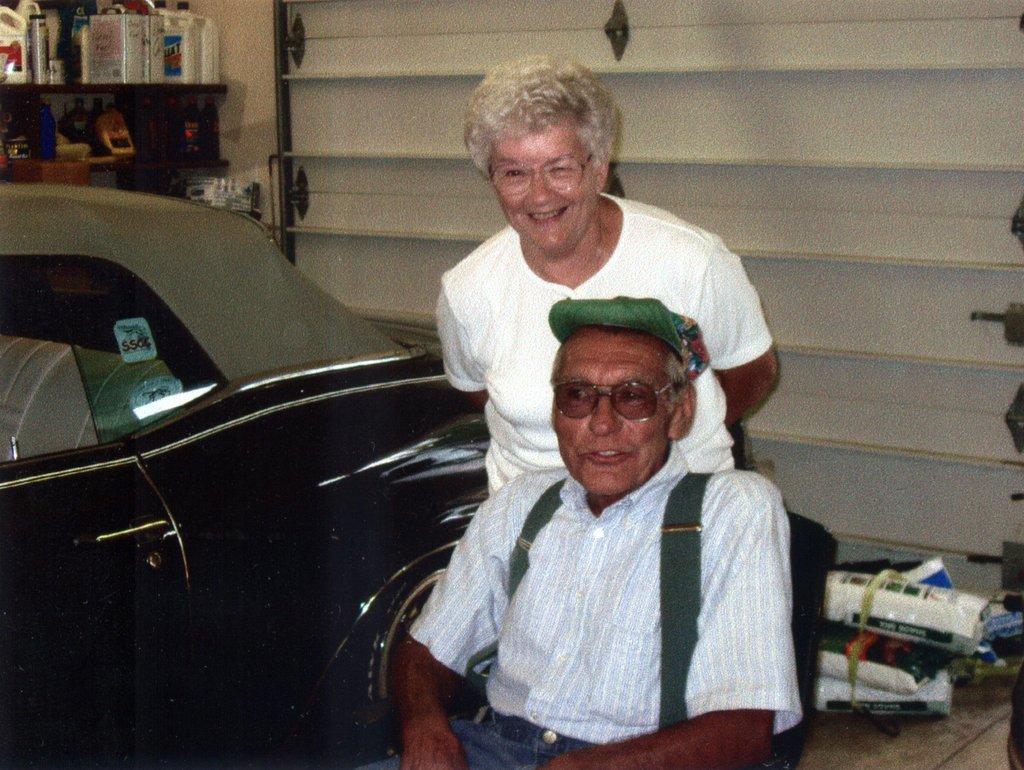How would you summarize this image in a sentence or two? In this image, we can see a person sitting on the chair. This person is wearing clothes and spectacles. There is an another person in front of the wall. There is a car on the left side of the image. There are bottles on the rack which is in the top left of the image. 